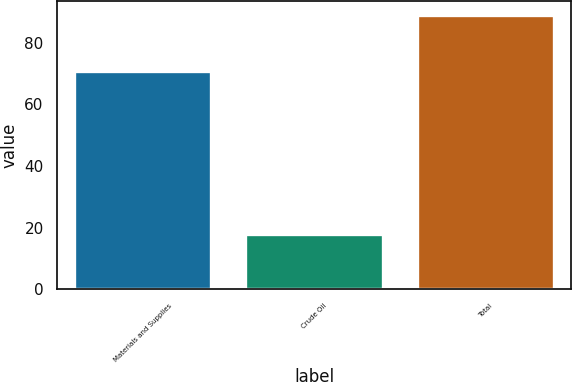Convert chart to OTSL. <chart><loc_0><loc_0><loc_500><loc_500><bar_chart><fcel>Materials and Supplies<fcel>Crude Oil<fcel>Total<nl><fcel>71<fcel>18<fcel>89<nl></chart> 